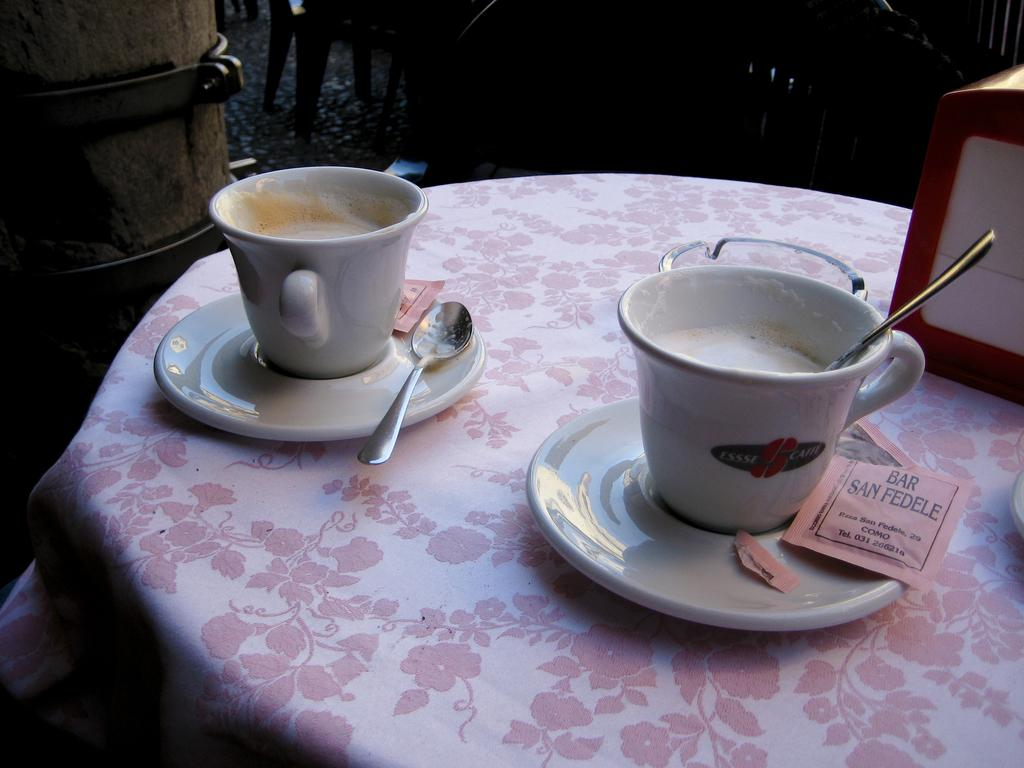What is in the cup that is visible in the image? There is coffee in a cup in the image. What utensils can be seen on the table in the image? There are spoons on the table in the image. What is located on the right side of the table in the image? There is an object on the right side of the table in the image. What can be seen in the background of the image? There is a chair in the background of the image. What is the daughter's reaction to the shameful behavior in the image? There is no daughter or shameful behavior present in the image. 